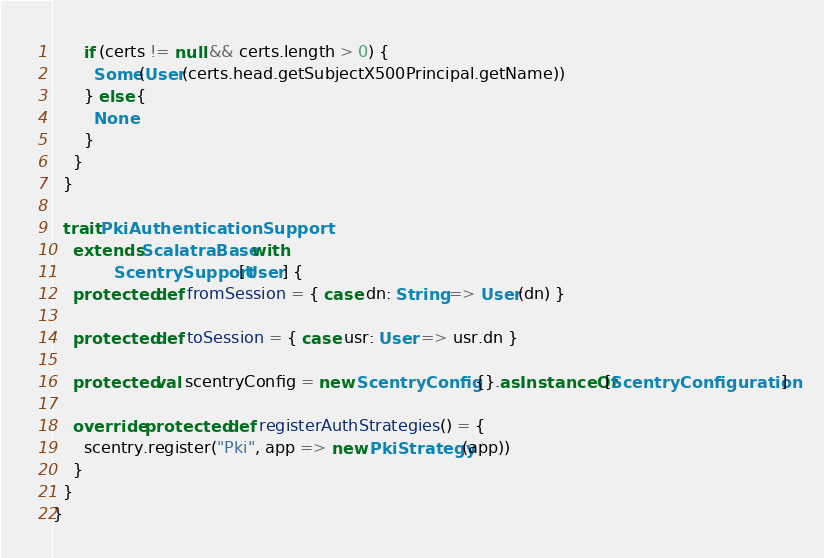<code> <loc_0><loc_0><loc_500><loc_500><_Scala_>      if (certs != null && certs.length > 0) {
        Some(User(certs.head.getSubjectX500Principal.getName))
      } else {
        None
      }
    }
  }

  trait PkiAuthenticationSupport
    extends ScalatraBase with
            ScentrySupport[User] {
    protected def fromSession = { case dn: String => User(dn) }

    protected def toSession = { case usr: User => usr.dn }

    protected val scentryConfig = new ScentryConfig {}.asInstanceOf[ScentryConfiguration]

    override protected def registerAuthStrategies() = {
      scentry.register("Pki", app => new PkiStrategy(app))
    }
  }
}
</code> 